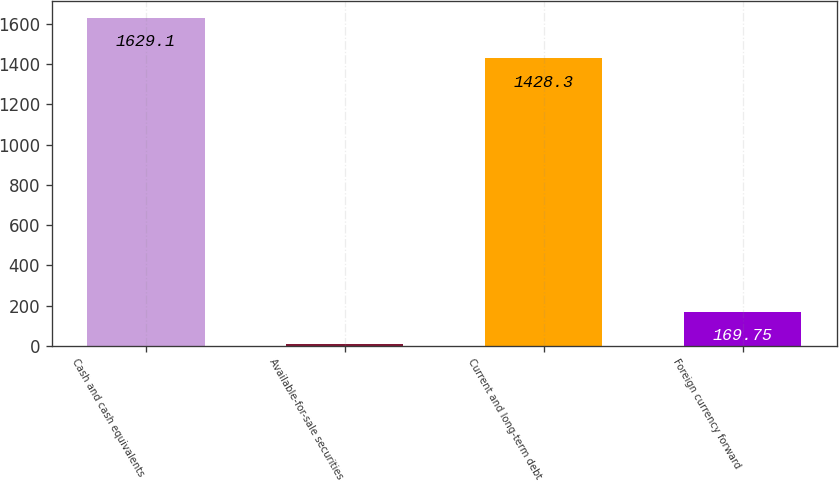Convert chart. <chart><loc_0><loc_0><loc_500><loc_500><bar_chart><fcel>Cash and cash equivalents<fcel>Available-for-sale securities<fcel>Current and long-term debt<fcel>Foreign currency forward<nl><fcel>1629.1<fcel>7.6<fcel>1428.3<fcel>169.75<nl></chart> 